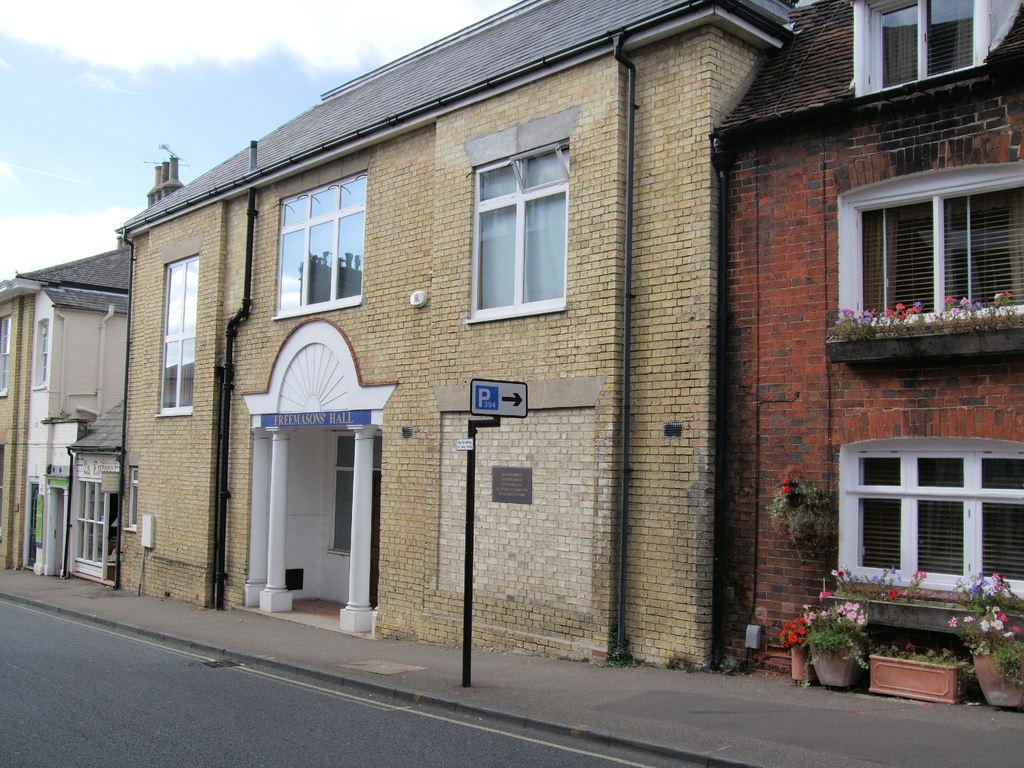Can you describe this image briefly? In this image we can see buildings, pipelines, name board, sign board, house plants, windows and sky in the background. 